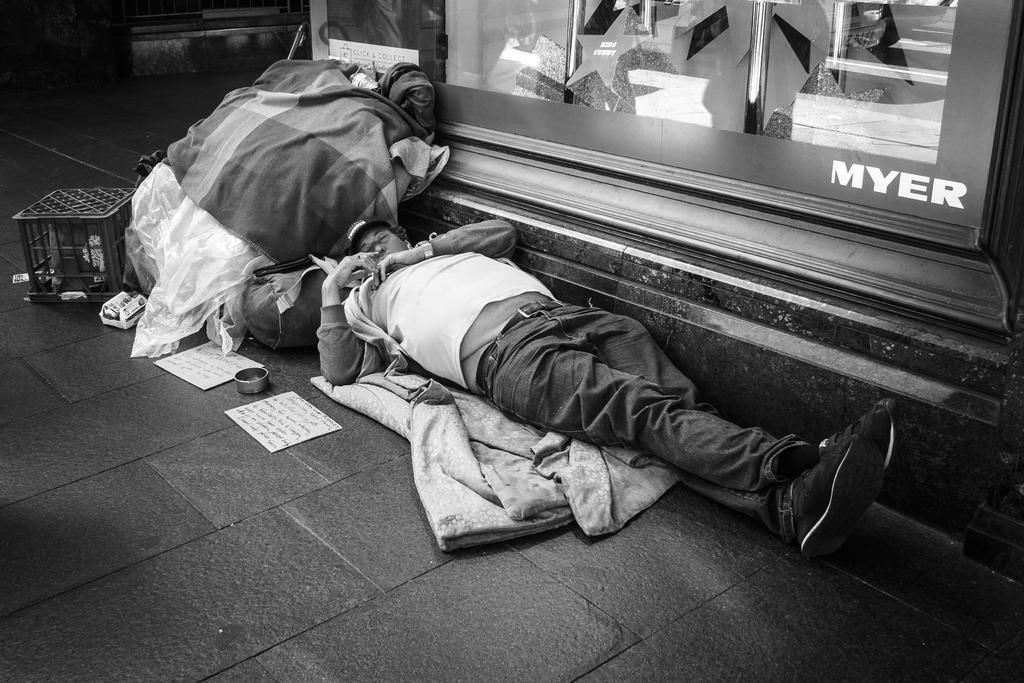Describe this image in one or two sentences. This is a black and white picture. We can see a man is lying on the cloth. On the left side of the man there are papers and behind the man there is another cloth, polythene cover and some objects. On the right side of the man there is a board. 